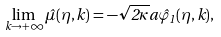Convert formula to latex. <formula><loc_0><loc_0><loc_500><loc_500>\lim _ { k \rightarrow + \infty } \hat { \mu } ( \eta , { k } ) = - \sqrt { 2 \kappa } a \hat { \varphi } _ { 1 } ( \eta , { k } ) ,</formula> 